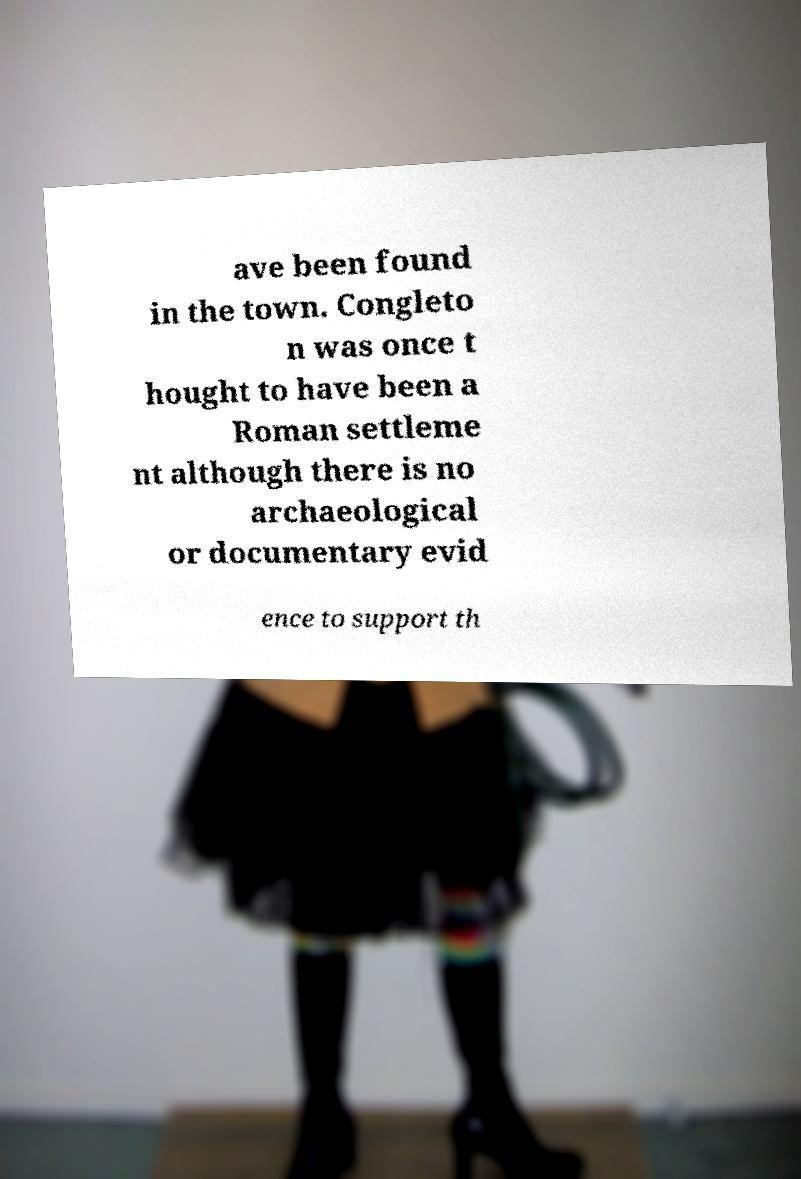Could you extract and type out the text from this image? ave been found in the town. Congleto n was once t hought to have been a Roman settleme nt although there is no archaeological or documentary evid ence to support th 